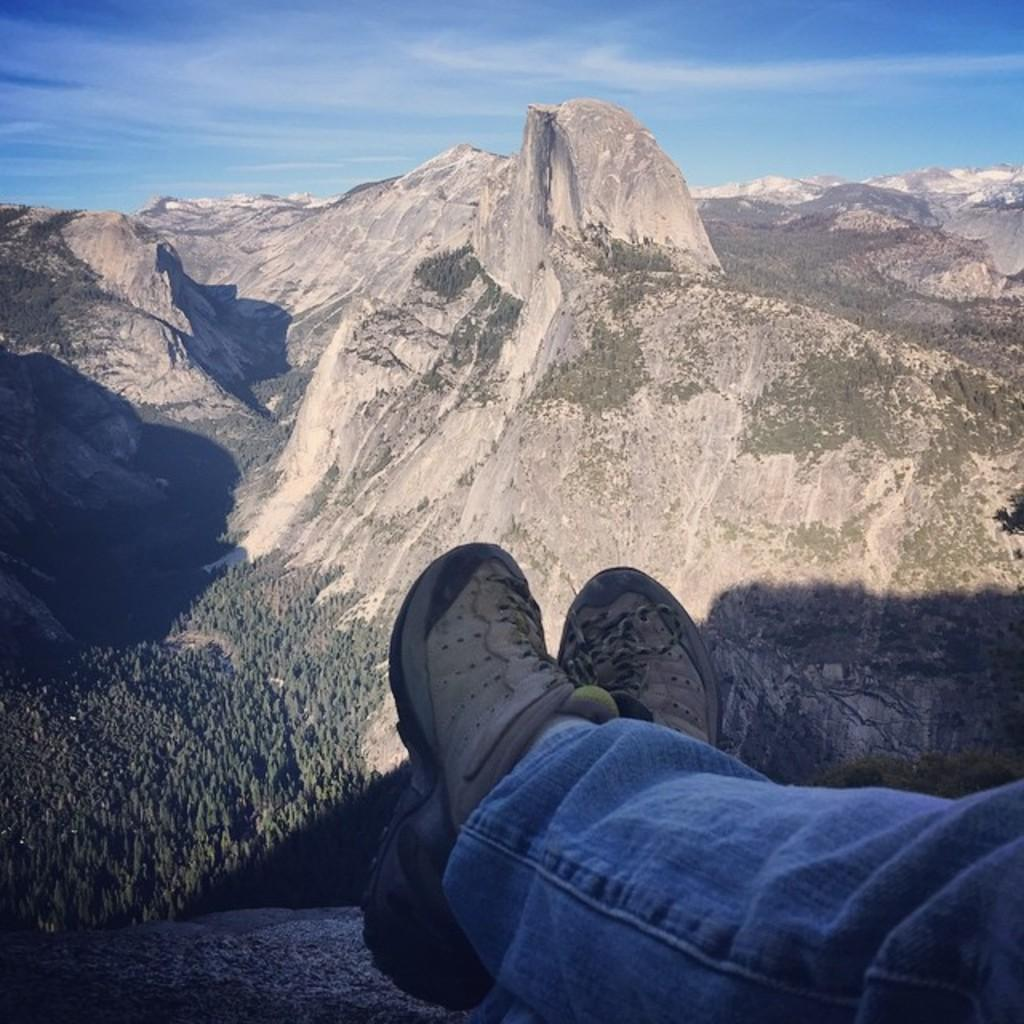What can be seen at the bottom of the image? There are two legs at the bottom side of the image. What type of natural environment is depicted in the image? There is greenery in the image. What can be seen in the distance in the image? There are mountains in the background of the image. What type of haircut does the family have in the image? There is no family present in the image, and therefore no haircuts can be observed. How does the ray interact with the greenery in the image? There are no rays present in the image; it features two legs, greenery, and mountains in the background. 